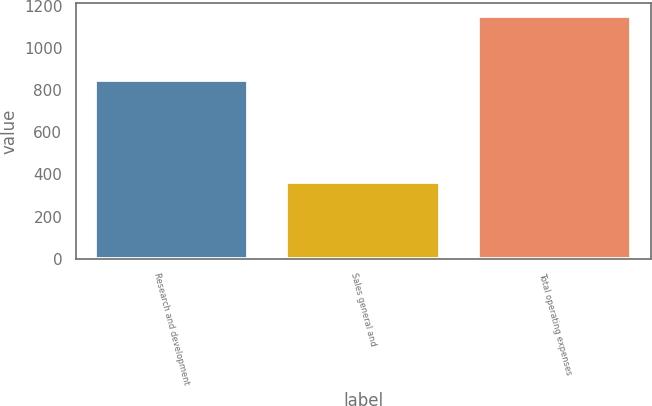<chart> <loc_0><loc_0><loc_500><loc_500><bar_chart><fcel>Research and development<fcel>Sales general and<fcel>Total operating expenses<nl><fcel>848.8<fcel>361.5<fcel>1153.3<nl></chart> 